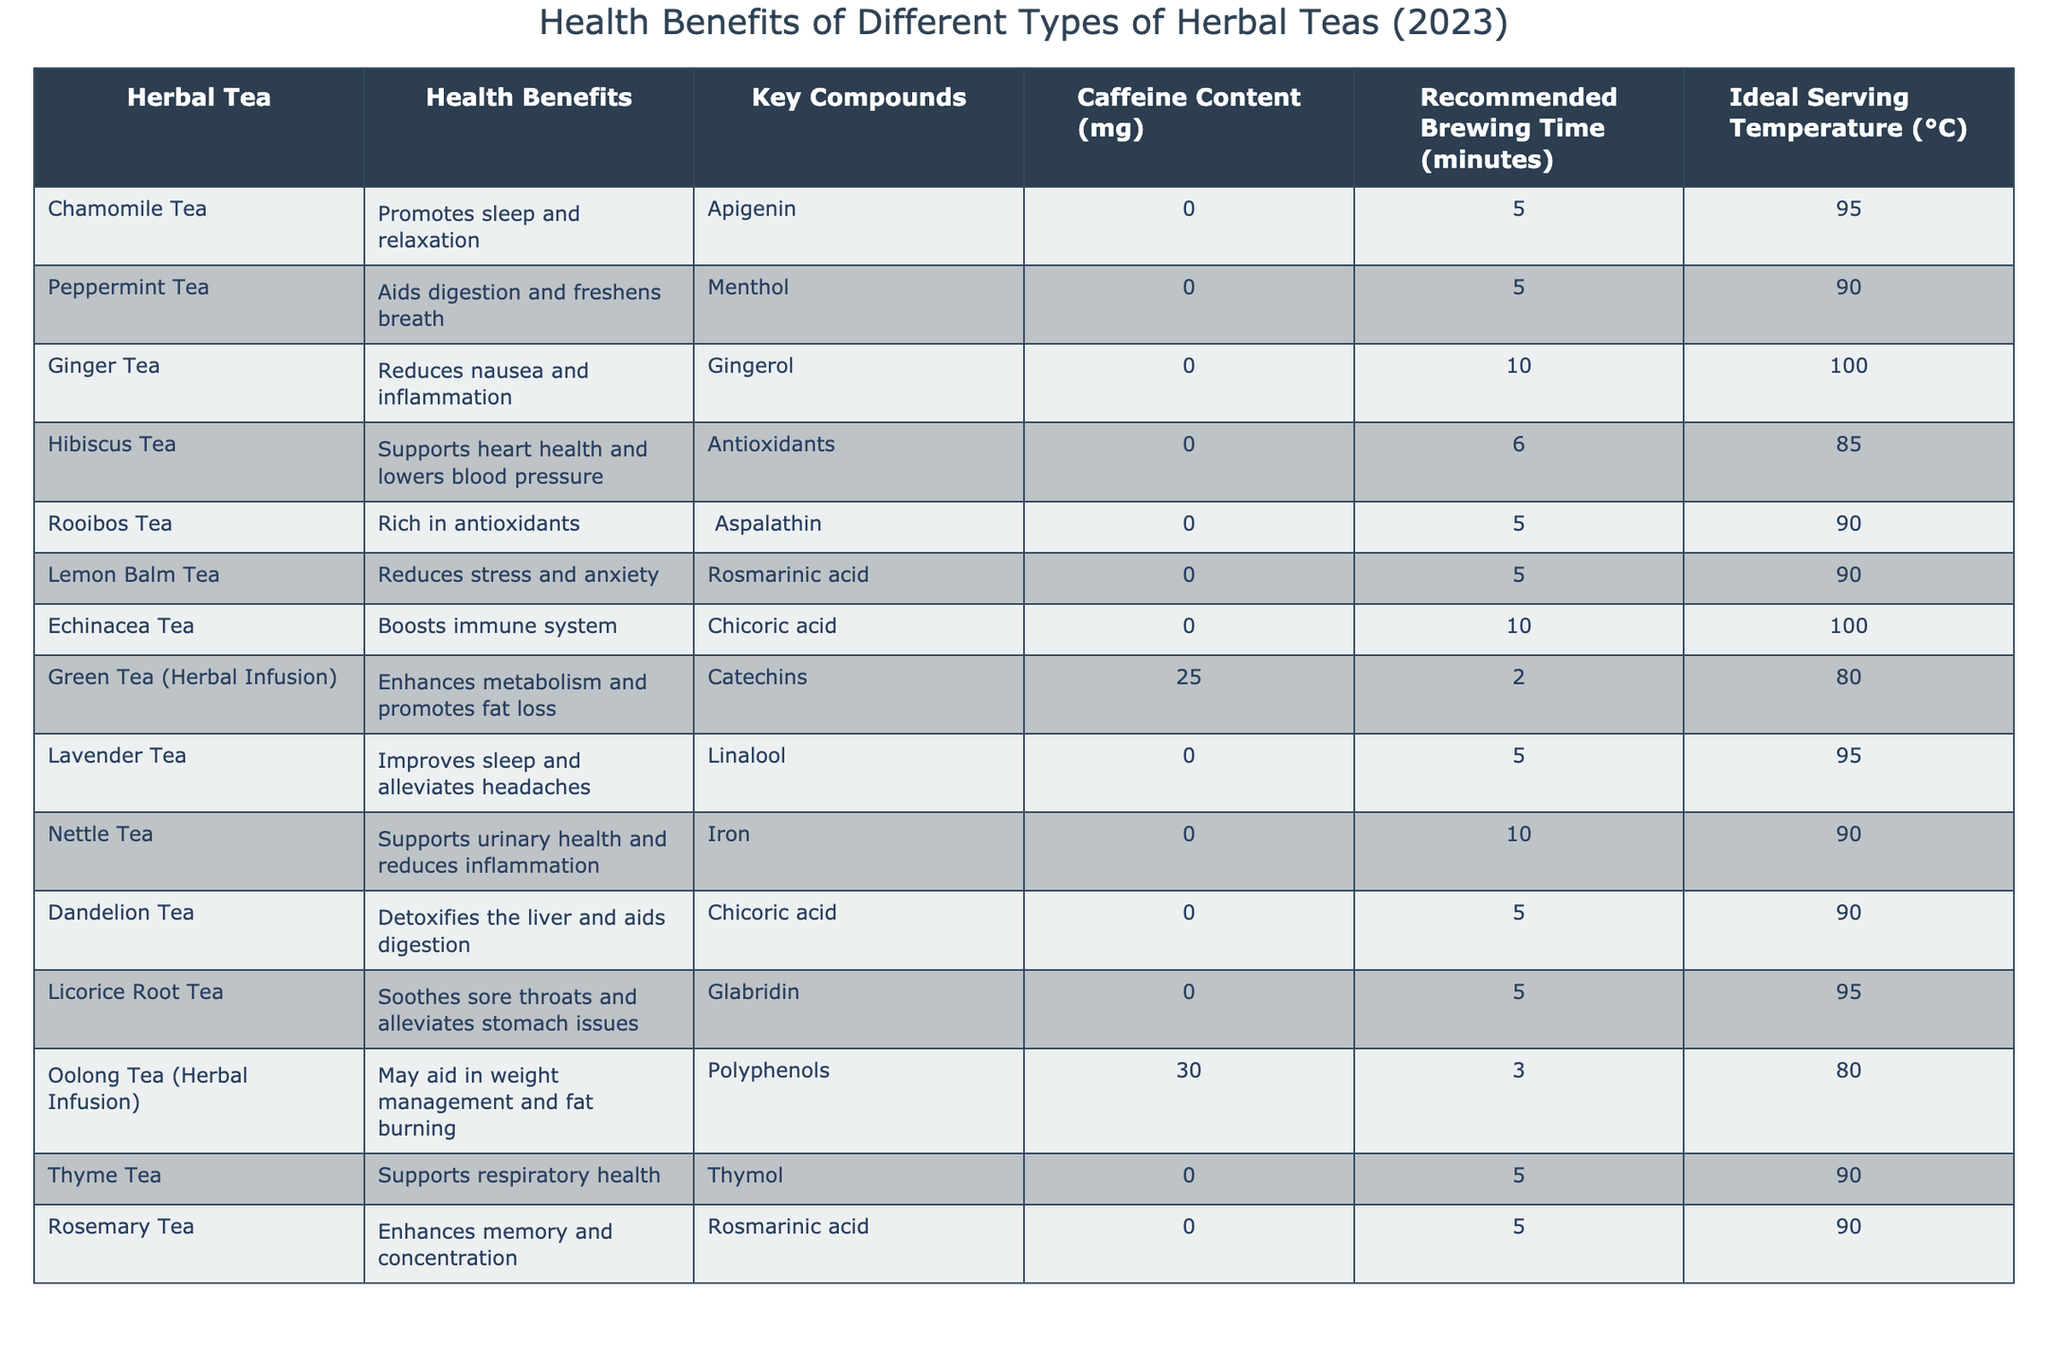What are the health benefits of Chamomile Tea? According to the table, Chamomile Tea promotes sleep and relaxation.
Answer: Promotes sleep and relaxation Which herbal tea contains caffeine? The table indicates that both Green Tea (Herbal Infusion) and Oolong Tea (Herbal Infusion) contain caffeine, specifically 25 mg and 30 mg, respectively.
Answer: Green and Oolong Teas How long should you brew Ginger Tea? The recommended brewing time for Ginger Tea is listed as 10 minutes in the table.
Answer: 10 minutes What is the ideal serving temperature for Hibiscus Tea? The table states that the ideal serving temperature for Hibiscus Tea is 85 degrees Celsius.
Answer: 85°C Does Rooibos Tea have any caffeine? The table shows that Rooibos Tea has 0 mg of caffeine, indicating it does not contain any.
Answer: No Which herbal tea supports urinary health? According to the table, Nettle Tea supports urinary health.
Answer: Nettle Tea What is the average caffeine content of Green Tea and Oolong Tea combined? The caffeine content for Green Tea is 25 mg and for Oolong Tea is 30 mg, giving a total of 55 mg. Therefore, the average is 55 mg / 2 = 27.5 mg.
Answer: 27.5 mg Which herbal tea has the highest recommended brewing time? The highest brewing time listed is for Ginger Tea and Echinacea Tea, both at 10 minutes.
Answer: Ginger and Echinacea Teas What are the key compounds found in Lemon Balm Tea? The table indicates that the key compound in Lemon Balm Tea is Rosmarinic acid.
Answer: Rosmarinic acid True or False: Dandelion Tea detoxifies the liver and aids digestion. The table confirms that Dandelion Tea is listed with the health benefit of detoxifying the liver and aiding digestion.
Answer: True Which herbal tea has the lowest ideal serving temperature? The lowest ideal serving temperature in the table is 80°C, which applies to both Green Tea and Oolong Tea.
Answer: Green and Oolong Teas How many herbal teas listed have no caffeine content? By reviewing the table, all teas except for Green Tea and Oolong Tea have 0 mg of caffeine, totaling 12 teas without caffeine.
Answer: 12 teas Which tea aids in digestion and freshens breath? The table specifies that Peppermint Tea aids in digestion and freshens breath.
Answer: Peppermint Tea What compound in Ginger Tea helps reduce nausea and inflammation? Ginger Tea contains Gingerol as its key compound, which helps reduce nausea and inflammation according to the table.
Answer: Gingerol What is the serving temperature difference between Lavender Tea and Hibiscus Tea? Lavender Tea's ideal serving temperature is 95°C and Hibiscus Tea's is 85°C; the difference is 95°C - 85°C = 10°C.
Answer: 10°C 